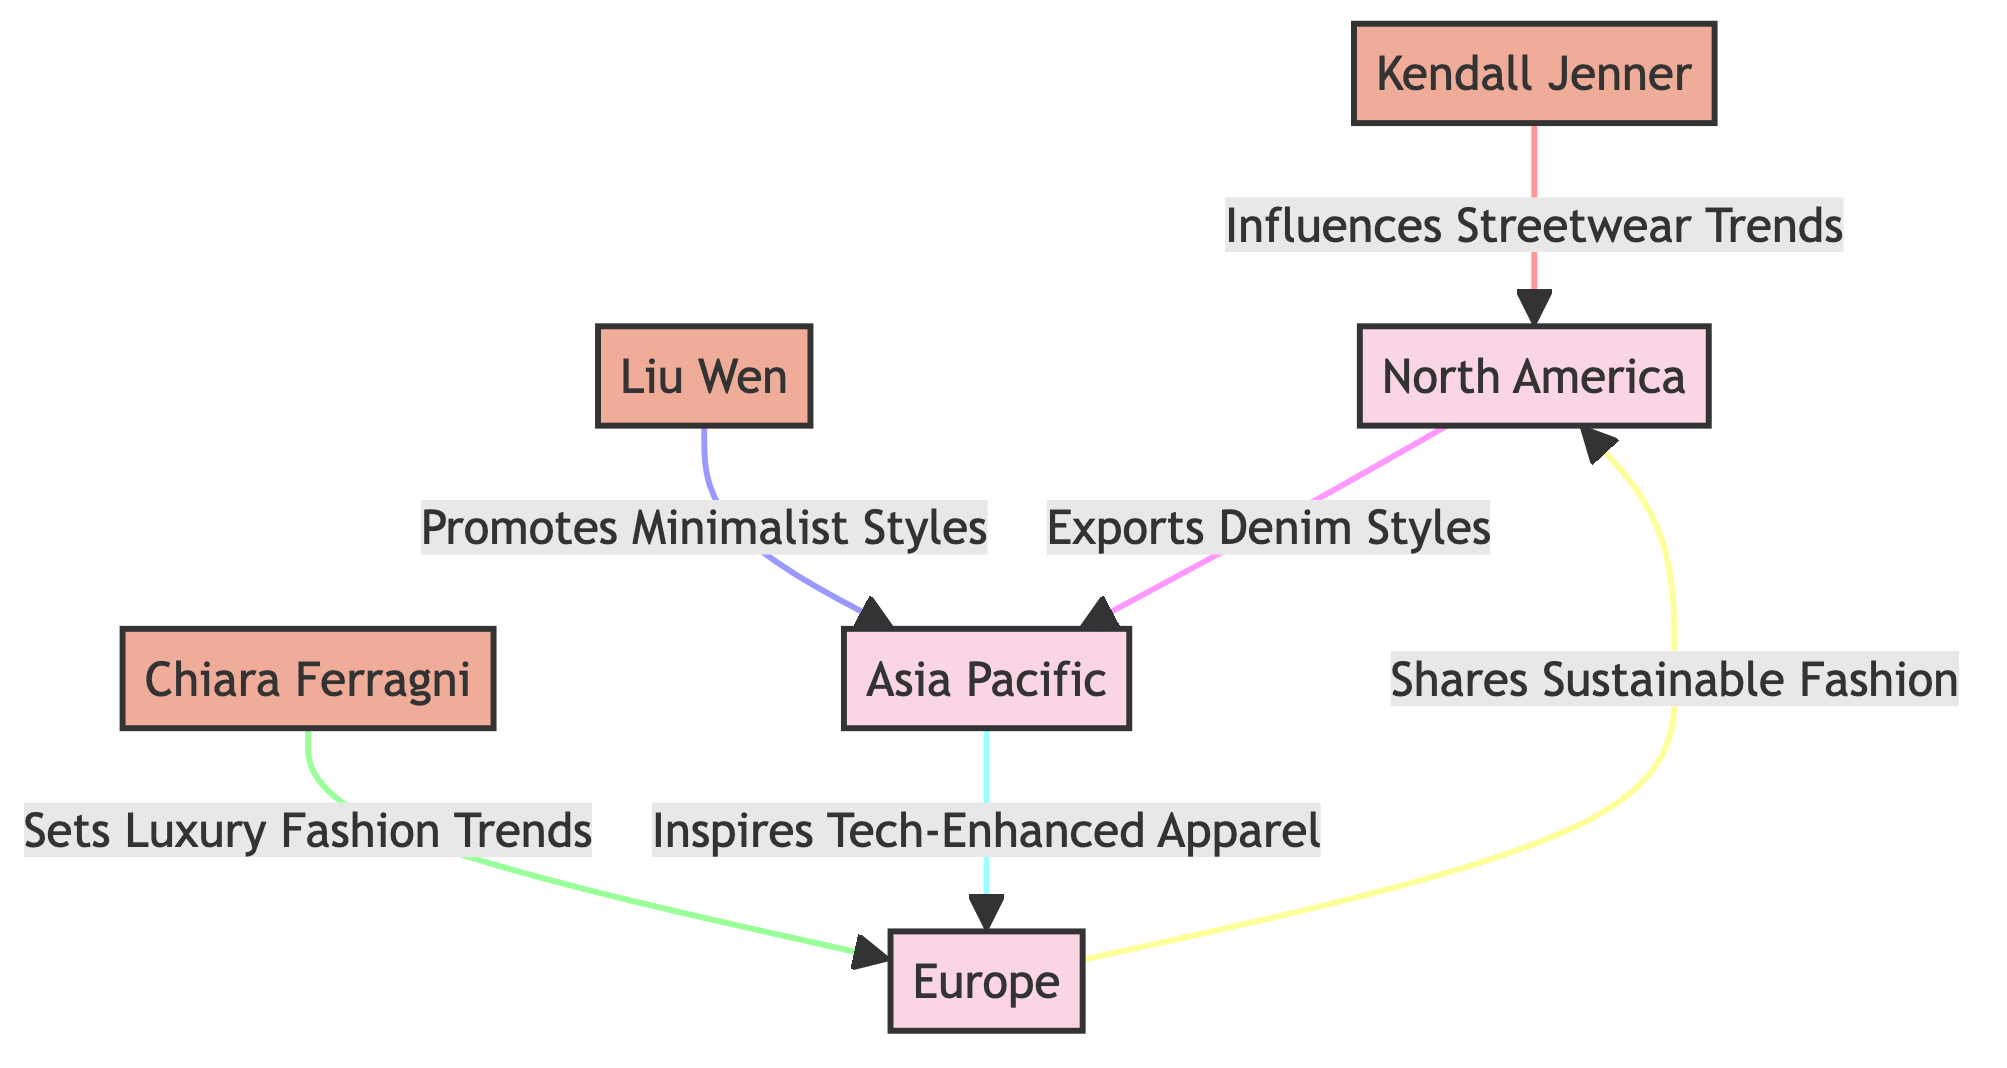What regions are influenced by Kendall Jenner? The diagram shows that Kendall Jenner influences trends in North America specifically, as indicated by the arrow pointing from her node to the North America node.
Answer: North America Which fashion trend does Chiara Ferragni set in Europe? According to the diagram, Chiara Ferragni sets luxury fashion trends, as specified by the text accompanying the link from her node to Europe.
Answer: Luxury Fashion Trends How many influencers are represented in the diagram? By counting the nodes labeled as influencers (Kendall Jenner, Chiara Ferragni, Liu Wen), we find there are three influencer nodes in total.
Answer: Three Which region inspires tech-enhanced apparel? The arrow leading from the Asia Pacific node to the Tech-Enhanced Apparel descriptor indicates that this region is the source of inspiration for this particular apparel type.
Answer: Asia Pacific What type of styles does Liu Wen promote? The diagram states that Liu Wen promotes minimalist styles, as reflected in the connection between her node and the corresponding style descriptor.
Answer: Minimalist Styles Which region exports denim styles? The link from North America to the denim styles node indicates that North America is responsible for exporting denim styles as shown in the diagram.
Answer: North America Which influencer is linked to sustainable fashion? The connection from Europe to sustainable fashion with another arrow indicates that Chiara Ferragni shares sustainable fashion, which connects her directly to this trend.
Answer: Chiara Ferragni Which influencing stars are associated with streetwear and luxury trends? Kendall Jenner is noted for influencing streetwear trends, while Chiara Ferragni is associated with luxury fashion trends, as indicated by their respective links in the diagram.
Answer: Kendall Jenner and Chiara Ferragni Which region has a connection to denim styles and also inspires tech-enhanced apparel? North America is linked to denim style exports and Asia Pacific is linked to inspiring tech-enhanced apparel. Hence, these two regions have a distinct connection to different apparel styles.
Answer: North America and Asia Pacific 